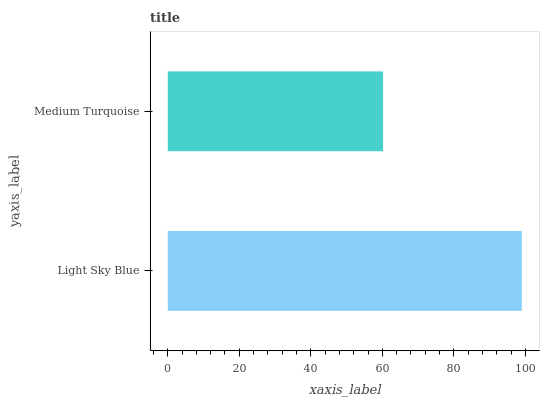Is Medium Turquoise the minimum?
Answer yes or no. Yes. Is Light Sky Blue the maximum?
Answer yes or no. Yes. Is Medium Turquoise the maximum?
Answer yes or no. No. Is Light Sky Blue greater than Medium Turquoise?
Answer yes or no. Yes. Is Medium Turquoise less than Light Sky Blue?
Answer yes or no. Yes. Is Medium Turquoise greater than Light Sky Blue?
Answer yes or no. No. Is Light Sky Blue less than Medium Turquoise?
Answer yes or no. No. Is Light Sky Blue the high median?
Answer yes or no. Yes. Is Medium Turquoise the low median?
Answer yes or no. Yes. Is Medium Turquoise the high median?
Answer yes or no. No. Is Light Sky Blue the low median?
Answer yes or no. No. 